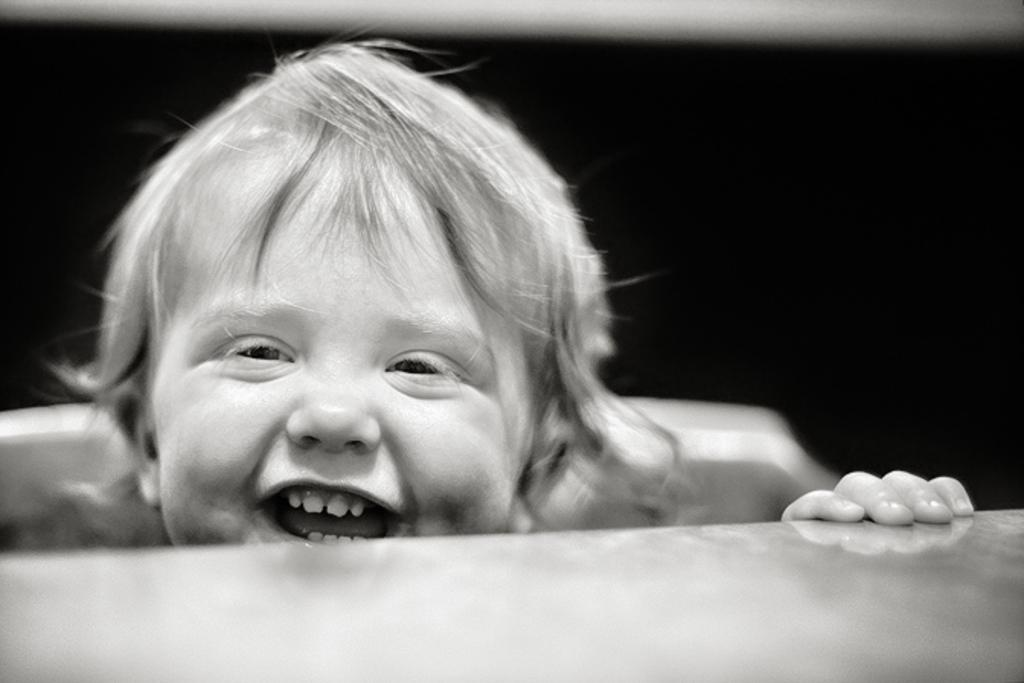What is the main subject of the image? There is a baby in the image. What is the baby doing in the image? The baby is smiling. Is there any furniture or objects visible in the image? Yes, there is a table at the bottom of the image. What type of fire can be seen in the background of the image? There is no fire present in the image; it features a baby smiling and a table at the bottom. 